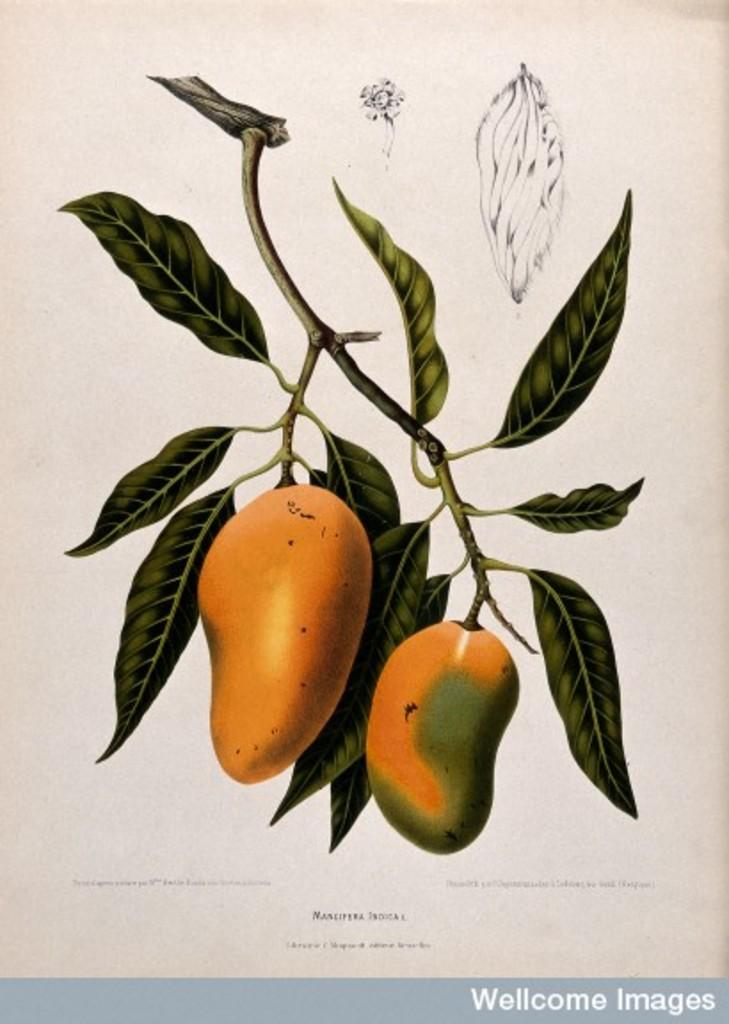What type of animated picture is in the image? The image contains an animated picture of a mango tree. What else can be seen in the image besides the animated picture? There is text present in the image. How many bushes are visible in the image? There are no bushes present in the image; it contains an animated picture of a mango tree and text. 